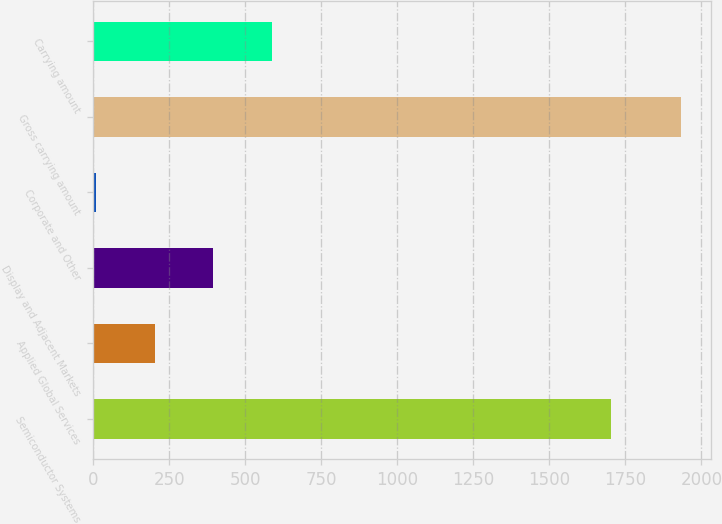Convert chart. <chart><loc_0><loc_0><loc_500><loc_500><bar_chart><fcel>Semiconductor Systems<fcel>Applied Global Services<fcel>Display and Adjacent Markets<fcel>Corporate and Other<fcel>Gross carrying amount<fcel>Carrying amount<nl><fcel>1701<fcel>202.4<fcel>394.8<fcel>10<fcel>1934<fcel>587.2<nl></chart> 